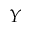Convert formula to latex. <formula><loc_0><loc_0><loc_500><loc_500>Y</formula> 